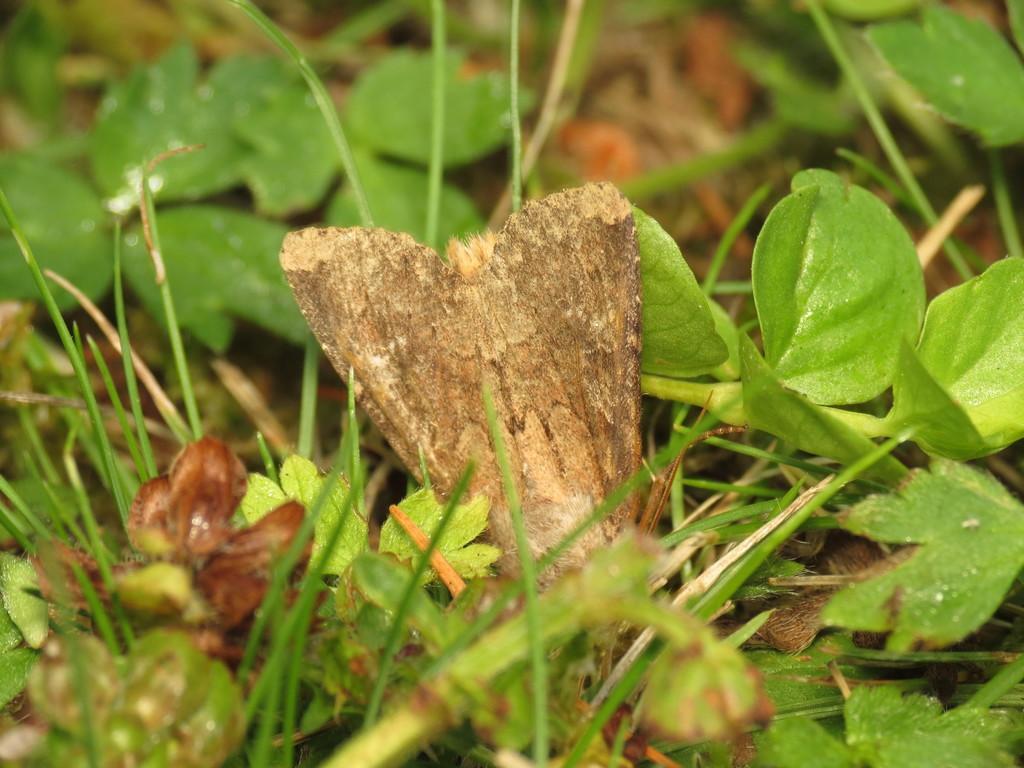Please provide a concise description of this image. In this image there is a brown color object in the middle. There is grass. There are leaves. There is sand. 